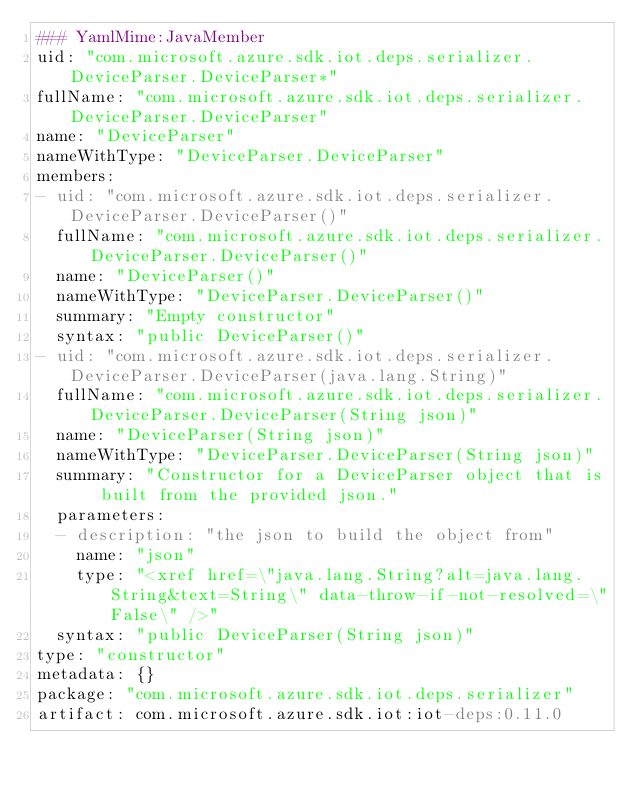Convert code to text. <code><loc_0><loc_0><loc_500><loc_500><_YAML_>### YamlMime:JavaMember
uid: "com.microsoft.azure.sdk.iot.deps.serializer.DeviceParser.DeviceParser*"
fullName: "com.microsoft.azure.sdk.iot.deps.serializer.DeviceParser.DeviceParser"
name: "DeviceParser"
nameWithType: "DeviceParser.DeviceParser"
members:
- uid: "com.microsoft.azure.sdk.iot.deps.serializer.DeviceParser.DeviceParser()"
  fullName: "com.microsoft.azure.sdk.iot.deps.serializer.DeviceParser.DeviceParser()"
  name: "DeviceParser()"
  nameWithType: "DeviceParser.DeviceParser()"
  summary: "Empty constructor"
  syntax: "public DeviceParser()"
- uid: "com.microsoft.azure.sdk.iot.deps.serializer.DeviceParser.DeviceParser(java.lang.String)"
  fullName: "com.microsoft.azure.sdk.iot.deps.serializer.DeviceParser.DeviceParser(String json)"
  name: "DeviceParser(String json)"
  nameWithType: "DeviceParser.DeviceParser(String json)"
  summary: "Constructor for a DeviceParser object that is built from the provided json."
  parameters:
  - description: "the json to build the object from"
    name: "json"
    type: "<xref href=\"java.lang.String?alt=java.lang.String&text=String\" data-throw-if-not-resolved=\"False\" />"
  syntax: "public DeviceParser(String json)"
type: "constructor"
metadata: {}
package: "com.microsoft.azure.sdk.iot.deps.serializer"
artifact: com.microsoft.azure.sdk.iot:iot-deps:0.11.0
</code> 